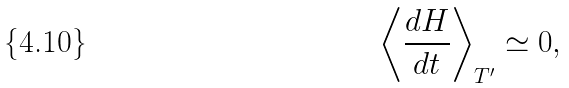<formula> <loc_0><loc_0><loc_500><loc_500>\left \langle \frac { d H } { d t } \right \rangle _ { T ^ { \prime } } \simeq 0 ,</formula> 